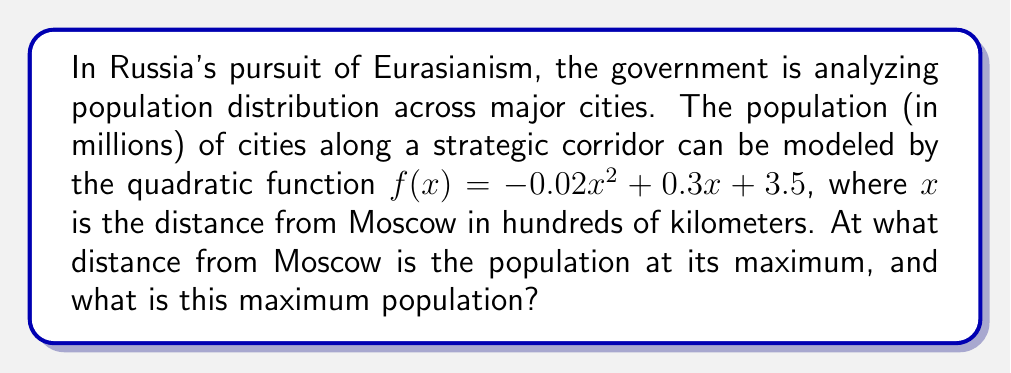Can you solve this math problem? To solve this problem, we'll follow these steps:

1) The quadratic function is in the form $f(x) = ax^2 + bx + c$, where:
   $a = -0.02$, $b = 0.3$, and $c = 3.5$

2) For a quadratic function, the x-coordinate of the vertex represents the point where the function reaches its maximum (if $a < 0$) or minimum (if $a > 0$).

3) The formula for the x-coordinate of the vertex is: $x = -\frac{b}{2a}$

4) Substituting our values:
   $$x = -\frac{0.3}{2(-0.02)} = -\frac{0.3}{-0.04} = 7.5$$

5) This means the population is at its maximum 750 km from Moscow (since x is in hundreds of kilometers).

6) To find the maximum population, we substitute x = 7.5 into our original function:

   $$f(7.5) = -0.02(7.5)^2 + 0.3(7.5) + 3.5$$
   $$= -0.02(56.25) + 2.25 + 3.5$$
   $$= -1.125 + 2.25 + 3.5$$
   $$= 4.625$$

Therefore, the maximum population is 4.625 million, occurring 750 km from Moscow.
Answer: 750 km from Moscow; 4.625 million people 